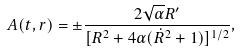<formula> <loc_0><loc_0><loc_500><loc_500>A ( t , r ) = \pm \frac { 2 \sqrt { \alpha } { R ^ { \prime } } } { [ { R ^ { 2 } + 4 { \alpha } ( { \dot { R } } ^ { 2 } + 1 ) } ] ^ { 1 / 2 } } ,</formula> 